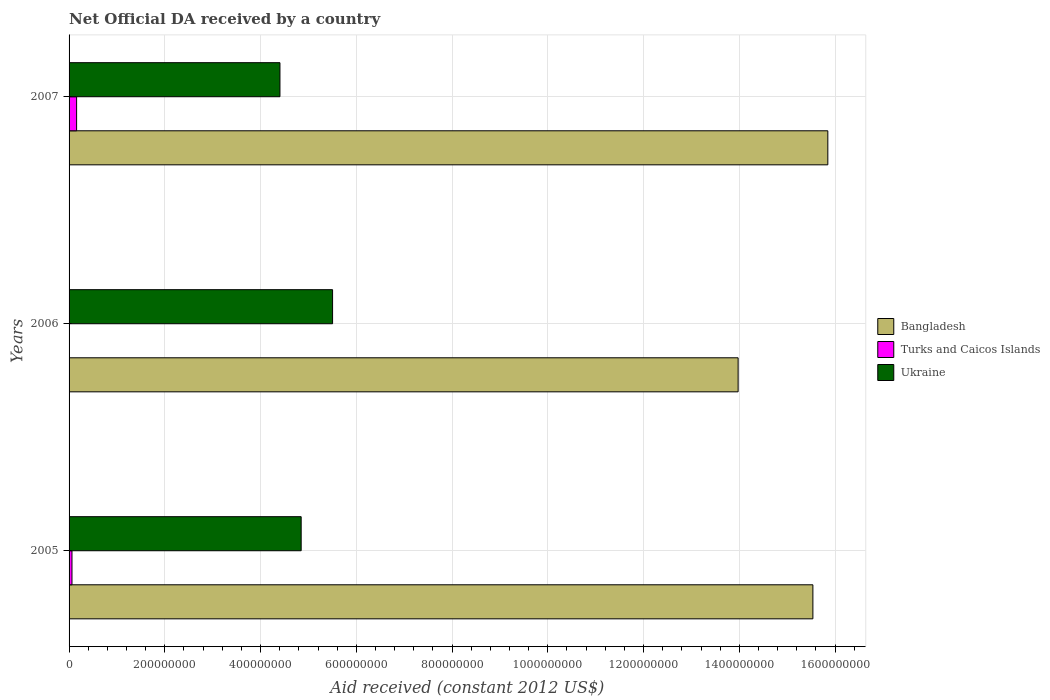Are the number of bars per tick equal to the number of legend labels?
Ensure brevity in your answer.  No. Are the number of bars on each tick of the Y-axis equal?
Your answer should be very brief. No. How many bars are there on the 3rd tick from the top?
Your answer should be very brief. 3. How many bars are there on the 3rd tick from the bottom?
Ensure brevity in your answer.  3. What is the label of the 3rd group of bars from the top?
Ensure brevity in your answer.  2005. In how many cases, is the number of bars for a given year not equal to the number of legend labels?
Make the answer very short. 1. What is the net official development assistance aid received in Bangladesh in 2005?
Make the answer very short. 1.55e+09. Across all years, what is the maximum net official development assistance aid received in Turks and Caicos Islands?
Your answer should be compact. 1.58e+07. Across all years, what is the minimum net official development assistance aid received in Bangladesh?
Make the answer very short. 1.40e+09. What is the total net official development assistance aid received in Ukraine in the graph?
Your answer should be very brief. 1.48e+09. What is the difference between the net official development assistance aid received in Bangladesh in 2005 and that in 2006?
Provide a short and direct response. 1.56e+08. What is the difference between the net official development assistance aid received in Ukraine in 2006 and the net official development assistance aid received in Bangladesh in 2007?
Make the answer very short. -1.03e+09. What is the average net official development assistance aid received in Ukraine per year?
Provide a short and direct response. 4.92e+08. In the year 2007, what is the difference between the net official development assistance aid received in Turks and Caicos Islands and net official development assistance aid received in Ukraine?
Your response must be concise. -4.25e+08. In how many years, is the net official development assistance aid received in Ukraine greater than 320000000 US$?
Make the answer very short. 3. What is the ratio of the net official development assistance aid received in Bangladesh in 2005 to that in 2007?
Your answer should be compact. 0.98. Is the net official development assistance aid received in Bangladesh in 2005 less than that in 2007?
Provide a short and direct response. Yes. Is the difference between the net official development assistance aid received in Turks and Caicos Islands in 2005 and 2007 greater than the difference between the net official development assistance aid received in Ukraine in 2005 and 2007?
Offer a terse response. No. What is the difference between the highest and the second highest net official development assistance aid received in Ukraine?
Make the answer very short. 6.56e+07. What is the difference between the highest and the lowest net official development assistance aid received in Ukraine?
Keep it short and to the point. 1.10e+08. In how many years, is the net official development assistance aid received in Ukraine greater than the average net official development assistance aid received in Ukraine taken over all years?
Your answer should be very brief. 1. Is the sum of the net official development assistance aid received in Bangladesh in 2006 and 2007 greater than the maximum net official development assistance aid received in Ukraine across all years?
Give a very brief answer. Yes. Is it the case that in every year, the sum of the net official development assistance aid received in Bangladesh and net official development assistance aid received in Turks and Caicos Islands is greater than the net official development assistance aid received in Ukraine?
Make the answer very short. Yes. Are all the bars in the graph horizontal?
Provide a short and direct response. Yes. What is the difference between two consecutive major ticks on the X-axis?
Your answer should be very brief. 2.00e+08. Where does the legend appear in the graph?
Offer a very short reply. Center right. How many legend labels are there?
Ensure brevity in your answer.  3. What is the title of the graph?
Offer a very short reply. Net Official DA received by a country. Does "Finland" appear as one of the legend labels in the graph?
Give a very brief answer. No. What is the label or title of the X-axis?
Keep it short and to the point. Aid received (constant 2012 US$). What is the label or title of the Y-axis?
Your response must be concise. Years. What is the Aid received (constant 2012 US$) in Bangladesh in 2005?
Provide a short and direct response. 1.55e+09. What is the Aid received (constant 2012 US$) of Turks and Caicos Islands in 2005?
Provide a short and direct response. 6.09e+06. What is the Aid received (constant 2012 US$) of Ukraine in 2005?
Make the answer very short. 4.85e+08. What is the Aid received (constant 2012 US$) of Bangladesh in 2006?
Give a very brief answer. 1.40e+09. What is the Aid received (constant 2012 US$) in Turks and Caicos Islands in 2006?
Ensure brevity in your answer.  0. What is the Aid received (constant 2012 US$) in Ukraine in 2006?
Give a very brief answer. 5.50e+08. What is the Aid received (constant 2012 US$) in Bangladesh in 2007?
Keep it short and to the point. 1.58e+09. What is the Aid received (constant 2012 US$) in Turks and Caicos Islands in 2007?
Your response must be concise. 1.58e+07. What is the Aid received (constant 2012 US$) of Ukraine in 2007?
Keep it short and to the point. 4.40e+08. Across all years, what is the maximum Aid received (constant 2012 US$) of Bangladesh?
Offer a very short reply. 1.58e+09. Across all years, what is the maximum Aid received (constant 2012 US$) of Turks and Caicos Islands?
Give a very brief answer. 1.58e+07. Across all years, what is the maximum Aid received (constant 2012 US$) of Ukraine?
Provide a short and direct response. 5.50e+08. Across all years, what is the minimum Aid received (constant 2012 US$) of Bangladesh?
Your response must be concise. 1.40e+09. Across all years, what is the minimum Aid received (constant 2012 US$) in Turks and Caicos Islands?
Offer a terse response. 0. Across all years, what is the minimum Aid received (constant 2012 US$) in Ukraine?
Your response must be concise. 4.40e+08. What is the total Aid received (constant 2012 US$) in Bangladesh in the graph?
Offer a terse response. 4.54e+09. What is the total Aid received (constant 2012 US$) in Turks and Caicos Islands in the graph?
Your answer should be compact. 2.18e+07. What is the total Aid received (constant 2012 US$) in Ukraine in the graph?
Provide a short and direct response. 1.48e+09. What is the difference between the Aid received (constant 2012 US$) in Bangladesh in 2005 and that in 2006?
Your answer should be very brief. 1.56e+08. What is the difference between the Aid received (constant 2012 US$) of Ukraine in 2005 and that in 2006?
Provide a succinct answer. -6.56e+07. What is the difference between the Aid received (constant 2012 US$) in Bangladesh in 2005 and that in 2007?
Give a very brief answer. -3.12e+07. What is the difference between the Aid received (constant 2012 US$) of Turks and Caicos Islands in 2005 and that in 2007?
Provide a succinct answer. -9.67e+06. What is the difference between the Aid received (constant 2012 US$) of Ukraine in 2005 and that in 2007?
Offer a very short reply. 4.43e+07. What is the difference between the Aid received (constant 2012 US$) of Bangladesh in 2006 and that in 2007?
Offer a terse response. -1.87e+08. What is the difference between the Aid received (constant 2012 US$) of Ukraine in 2006 and that in 2007?
Make the answer very short. 1.10e+08. What is the difference between the Aid received (constant 2012 US$) in Bangladesh in 2005 and the Aid received (constant 2012 US$) in Ukraine in 2006?
Provide a succinct answer. 1.00e+09. What is the difference between the Aid received (constant 2012 US$) of Turks and Caicos Islands in 2005 and the Aid received (constant 2012 US$) of Ukraine in 2006?
Your response must be concise. -5.44e+08. What is the difference between the Aid received (constant 2012 US$) in Bangladesh in 2005 and the Aid received (constant 2012 US$) in Turks and Caicos Islands in 2007?
Your response must be concise. 1.54e+09. What is the difference between the Aid received (constant 2012 US$) of Bangladesh in 2005 and the Aid received (constant 2012 US$) of Ukraine in 2007?
Keep it short and to the point. 1.11e+09. What is the difference between the Aid received (constant 2012 US$) in Turks and Caicos Islands in 2005 and the Aid received (constant 2012 US$) in Ukraine in 2007?
Your answer should be compact. -4.34e+08. What is the difference between the Aid received (constant 2012 US$) of Bangladesh in 2006 and the Aid received (constant 2012 US$) of Turks and Caicos Islands in 2007?
Ensure brevity in your answer.  1.38e+09. What is the difference between the Aid received (constant 2012 US$) in Bangladesh in 2006 and the Aid received (constant 2012 US$) in Ukraine in 2007?
Make the answer very short. 9.57e+08. What is the average Aid received (constant 2012 US$) of Bangladesh per year?
Ensure brevity in your answer.  1.51e+09. What is the average Aid received (constant 2012 US$) in Turks and Caicos Islands per year?
Offer a terse response. 7.28e+06. What is the average Aid received (constant 2012 US$) in Ukraine per year?
Offer a very short reply. 4.92e+08. In the year 2005, what is the difference between the Aid received (constant 2012 US$) in Bangladesh and Aid received (constant 2012 US$) in Turks and Caicos Islands?
Your answer should be very brief. 1.55e+09. In the year 2005, what is the difference between the Aid received (constant 2012 US$) in Bangladesh and Aid received (constant 2012 US$) in Ukraine?
Make the answer very short. 1.07e+09. In the year 2005, what is the difference between the Aid received (constant 2012 US$) in Turks and Caicos Islands and Aid received (constant 2012 US$) in Ukraine?
Your response must be concise. -4.79e+08. In the year 2006, what is the difference between the Aid received (constant 2012 US$) of Bangladesh and Aid received (constant 2012 US$) of Ukraine?
Your response must be concise. 8.47e+08. In the year 2007, what is the difference between the Aid received (constant 2012 US$) in Bangladesh and Aid received (constant 2012 US$) in Turks and Caicos Islands?
Offer a terse response. 1.57e+09. In the year 2007, what is the difference between the Aid received (constant 2012 US$) of Bangladesh and Aid received (constant 2012 US$) of Ukraine?
Your answer should be very brief. 1.14e+09. In the year 2007, what is the difference between the Aid received (constant 2012 US$) in Turks and Caicos Islands and Aid received (constant 2012 US$) in Ukraine?
Ensure brevity in your answer.  -4.25e+08. What is the ratio of the Aid received (constant 2012 US$) in Bangladesh in 2005 to that in 2006?
Give a very brief answer. 1.11. What is the ratio of the Aid received (constant 2012 US$) of Ukraine in 2005 to that in 2006?
Provide a short and direct response. 0.88. What is the ratio of the Aid received (constant 2012 US$) in Bangladesh in 2005 to that in 2007?
Make the answer very short. 0.98. What is the ratio of the Aid received (constant 2012 US$) of Turks and Caicos Islands in 2005 to that in 2007?
Ensure brevity in your answer.  0.39. What is the ratio of the Aid received (constant 2012 US$) in Ukraine in 2005 to that in 2007?
Your answer should be very brief. 1.1. What is the ratio of the Aid received (constant 2012 US$) of Bangladesh in 2006 to that in 2007?
Keep it short and to the point. 0.88. What is the ratio of the Aid received (constant 2012 US$) of Ukraine in 2006 to that in 2007?
Give a very brief answer. 1.25. What is the difference between the highest and the second highest Aid received (constant 2012 US$) in Bangladesh?
Give a very brief answer. 3.12e+07. What is the difference between the highest and the second highest Aid received (constant 2012 US$) of Ukraine?
Your answer should be compact. 6.56e+07. What is the difference between the highest and the lowest Aid received (constant 2012 US$) in Bangladesh?
Provide a short and direct response. 1.87e+08. What is the difference between the highest and the lowest Aid received (constant 2012 US$) in Turks and Caicos Islands?
Offer a terse response. 1.58e+07. What is the difference between the highest and the lowest Aid received (constant 2012 US$) of Ukraine?
Give a very brief answer. 1.10e+08. 